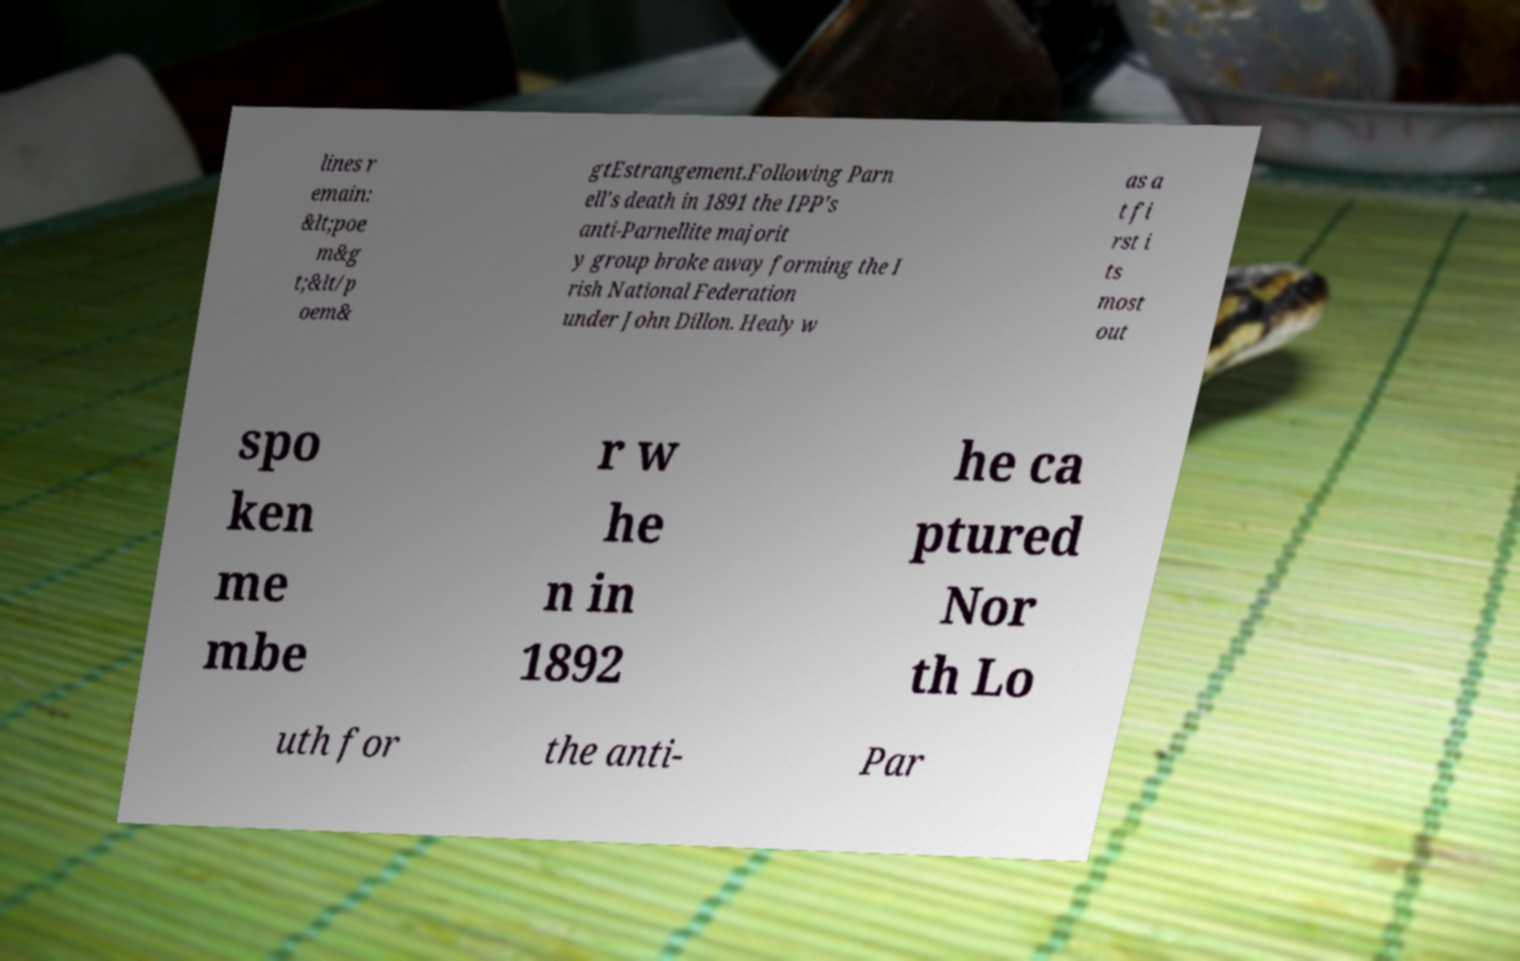What messages or text are displayed in this image? I need them in a readable, typed format. lines r emain: &lt;poe m&g t;&lt/p oem& gtEstrangement.Following Parn ell's death in 1891 the IPP's anti-Parnellite majorit y group broke away forming the I rish National Federation under John Dillon. Healy w as a t fi rst i ts most out spo ken me mbe r w he n in 1892 he ca ptured Nor th Lo uth for the anti- Par 